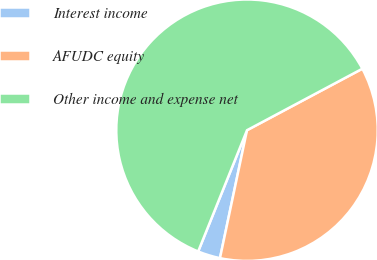<chart> <loc_0><loc_0><loc_500><loc_500><pie_chart><fcel>Interest income<fcel>AFUDC equity<fcel>Other income and expense net<nl><fcel>2.78%<fcel>36.11%<fcel>61.11%<nl></chart> 